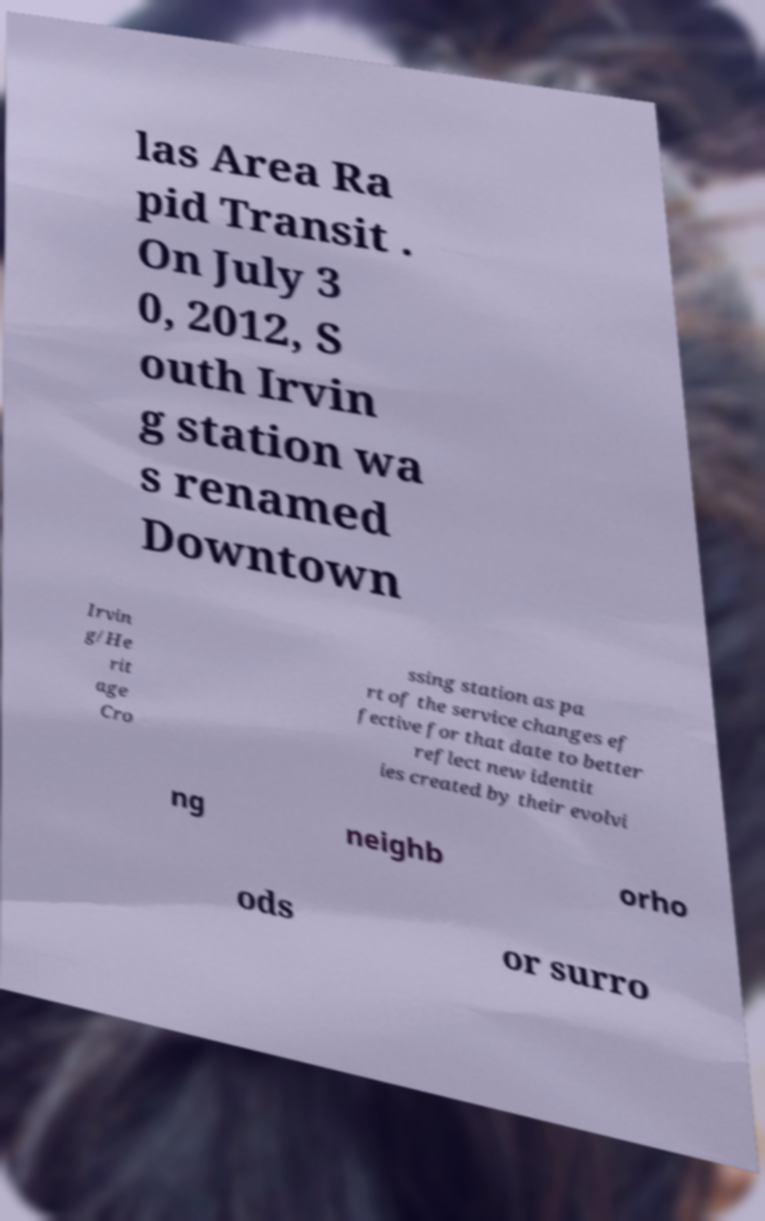What messages or text are displayed in this image? I need them in a readable, typed format. las Area Ra pid Transit . On July 3 0, 2012, S outh Irvin g station wa s renamed Downtown Irvin g/He rit age Cro ssing station as pa rt of the service changes ef fective for that date to better reflect new identit ies created by their evolvi ng neighb orho ods or surro 